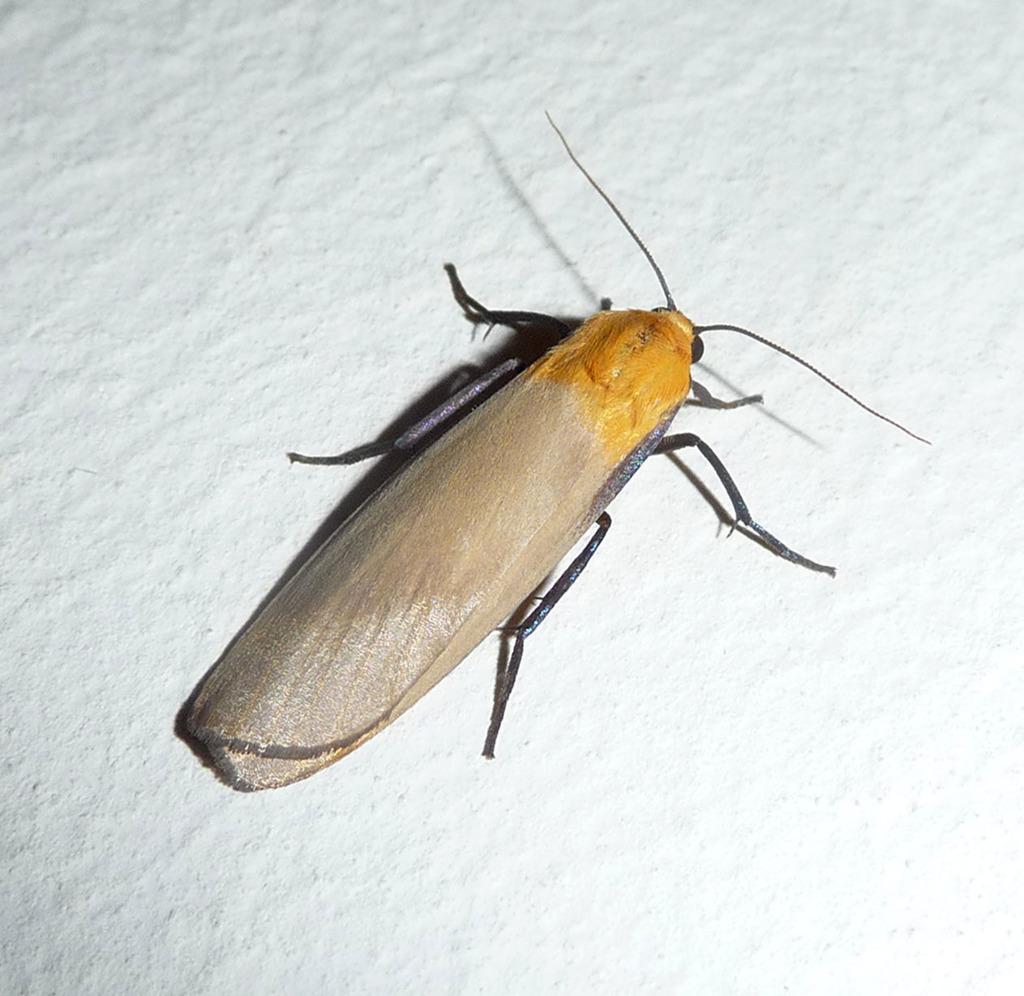In one or two sentences, can you explain what this image depicts? In this image, we can see an insect on the white colored surface. 